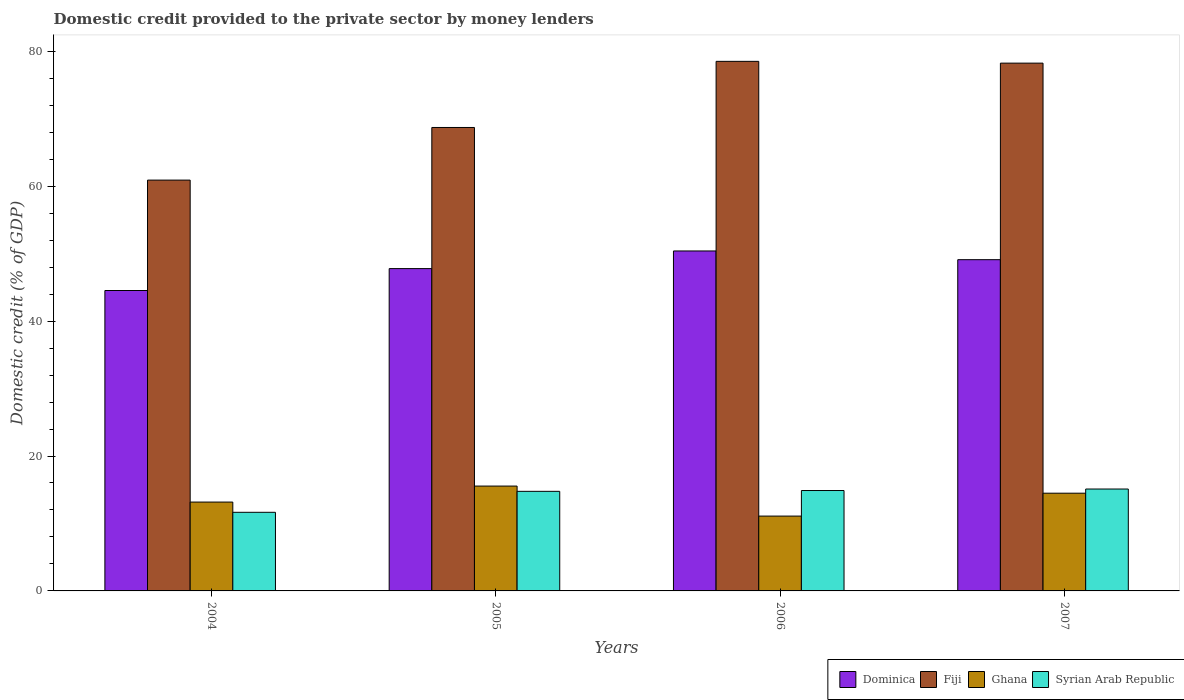How many groups of bars are there?
Ensure brevity in your answer.  4. Are the number of bars on each tick of the X-axis equal?
Your response must be concise. Yes. How many bars are there on the 4th tick from the right?
Your response must be concise. 4. In how many cases, is the number of bars for a given year not equal to the number of legend labels?
Keep it short and to the point. 0. What is the domestic credit provided to the private sector by money lenders in Ghana in 2005?
Ensure brevity in your answer.  15.54. Across all years, what is the maximum domestic credit provided to the private sector by money lenders in Ghana?
Make the answer very short. 15.54. Across all years, what is the minimum domestic credit provided to the private sector by money lenders in Ghana?
Give a very brief answer. 11.09. In which year was the domestic credit provided to the private sector by money lenders in Ghana maximum?
Make the answer very short. 2005. In which year was the domestic credit provided to the private sector by money lenders in Ghana minimum?
Ensure brevity in your answer.  2006. What is the total domestic credit provided to the private sector by money lenders in Dominica in the graph?
Offer a terse response. 191.83. What is the difference between the domestic credit provided to the private sector by money lenders in Ghana in 2004 and that in 2005?
Provide a short and direct response. -2.37. What is the difference between the domestic credit provided to the private sector by money lenders in Syrian Arab Republic in 2005 and the domestic credit provided to the private sector by money lenders in Ghana in 2004?
Ensure brevity in your answer.  1.59. What is the average domestic credit provided to the private sector by money lenders in Syrian Arab Republic per year?
Provide a succinct answer. 14.1. In the year 2007, what is the difference between the domestic credit provided to the private sector by money lenders in Fiji and domestic credit provided to the private sector by money lenders in Ghana?
Make the answer very short. 63.76. In how many years, is the domestic credit provided to the private sector by money lenders in Fiji greater than 28 %?
Ensure brevity in your answer.  4. What is the ratio of the domestic credit provided to the private sector by money lenders in Ghana in 2006 to that in 2007?
Give a very brief answer. 0.77. Is the domestic credit provided to the private sector by money lenders in Fiji in 2004 less than that in 2005?
Your response must be concise. Yes. Is the difference between the domestic credit provided to the private sector by money lenders in Fiji in 2004 and 2005 greater than the difference between the domestic credit provided to the private sector by money lenders in Ghana in 2004 and 2005?
Offer a very short reply. No. What is the difference between the highest and the second highest domestic credit provided to the private sector by money lenders in Dominica?
Provide a short and direct response. 1.29. What is the difference between the highest and the lowest domestic credit provided to the private sector by money lenders in Fiji?
Give a very brief answer. 17.6. Is the sum of the domestic credit provided to the private sector by money lenders in Dominica in 2004 and 2006 greater than the maximum domestic credit provided to the private sector by money lenders in Ghana across all years?
Your answer should be compact. Yes. Is it the case that in every year, the sum of the domestic credit provided to the private sector by money lenders in Fiji and domestic credit provided to the private sector by money lenders in Syrian Arab Republic is greater than the sum of domestic credit provided to the private sector by money lenders in Ghana and domestic credit provided to the private sector by money lenders in Dominica?
Make the answer very short. Yes. What does the 2nd bar from the left in 2007 represents?
Keep it short and to the point. Fiji. How many years are there in the graph?
Your response must be concise. 4. Are the values on the major ticks of Y-axis written in scientific E-notation?
Your response must be concise. No. Does the graph contain grids?
Provide a short and direct response. No. Where does the legend appear in the graph?
Your answer should be very brief. Bottom right. How are the legend labels stacked?
Ensure brevity in your answer.  Horizontal. What is the title of the graph?
Your answer should be very brief. Domestic credit provided to the private sector by money lenders. What is the label or title of the Y-axis?
Keep it short and to the point. Domestic credit (% of GDP). What is the Domestic credit (% of GDP) of Dominica in 2004?
Ensure brevity in your answer.  44.54. What is the Domestic credit (% of GDP) of Fiji in 2004?
Offer a very short reply. 60.91. What is the Domestic credit (% of GDP) of Ghana in 2004?
Make the answer very short. 13.17. What is the Domestic credit (% of GDP) in Syrian Arab Republic in 2004?
Make the answer very short. 11.65. What is the Domestic credit (% of GDP) in Dominica in 2005?
Provide a short and direct response. 47.78. What is the Domestic credit (% of GDP) in Fiji in 2005?
Your response must be concise. 68.71. What is the Domestic credit (% of GDP) of Ghana in 2005?
Give a very brief answer. 15.54. What is the Domestic credit (% of GDP) in Syrian Arab Republic in 2005?
Ensure brevity in your answer.  14.76. What is the Domestic credit (% of GDP) in Dominica in 2006?
Provide a succinct answer. 50.4. What is the Domestic credit (% of GDP) of Fiji in 2006?
Make the answer very short. 78.51. What is the Domestic credit (% of GDP) of Ghana in 2006?
Offer a terse response. 11.09. What is the Domestic credit (% of GDP) in Syrian Arab Republic in 2006?
Your response must be concise. 14.88. What is the Domestic credit (% of GDP) of Dominica in 2007?
Offer a very short reply. 49.11. What is the Domestic credit (% of GDP) in Fiji in 2007?
Give a very brief answer. 78.25. What is the Domestic credit (% of GDP) of Ghana in 2007?
Offer a terse response. 14.49. What is the Domestic credit (% of GDP) of Syrian Arab Republic in 2007?
Your answer should be very brief. 15.11. Across all years, what is the maximum Domestic credit (% of GDP) in Dominica?
Make the answer very short. 50.4. Across all years, what is the maximum Domestic credit (% of GDP) of Fiji?
Give a very brief answer. 78.51. Across all years, what is the maximum Domestic credit (% of GDP) of Ghana?
Make the answer very short. 15.54. Across all years, what is the maximum Domestic credit (% of GDP) in Syrian Arab Republic?
Your response must be concise. 15.11. Across all years, what is the minimum Domestic credit (% of GDP) of Dominica?
Your response must be concise. 44.54. Across all years, what is the minimum Domestic credit (% of GDP) in Fiji?
Your answer should be compact. 60.91. Across all years, what is the minimum Domestic credit (% of GDP) in Ghana?
Offer a terse response. 11.09. Across all years, what is the minimum Domestic credit (% of GDP) in Syrian Arab Republic?
Offer a terse response. 11.65. What is the total Domestic credit (% of GDP) in Dominica in the graph?
Offer a very short reply. 191.83. What is the total Domestic credit (% of GDP) in Fiji in the graph?
Provide a succinct answer. 286.37. What is the total Domestic credit (% of GDP) in Ghana in the graph?
Provide a short and direct response. 54.3. What is the total Domestic credit (% of GDP) of Syrian Arab Republic in the graph?
Your answer should be very brief. 56.41. What is the difference between the Domestic credit (% of GDP) of Dominica in 2004 and that in 2005?
Provide a short and direct response. -3.25. What is the difference between the Domestic credit (% of GDP) in Fiji in 2004 and that in 2005?
Ensure brevity in your answer.  -7.8. What is the difference between the Domestic credit (% of GDP) in Ghana in 2004 and that in 2005?
Your answer should be compact. -2.37. What is the difference between the Domestic credit (% of GDP) in Syrian Arab Republic in 2004 and that in 2005?
Ensure brevity in your answer.  -3.11. What is the difference between the Domestic credit (% of GDP) in Dominica in 2004 and that in 2006?
Keep it short and to the point. -5.86. What is the difference between the Domestic credit (% of GDP) in Fiji in 2004 and that in 2006?
Provide a succinct answer. -17.6. What is the difference between the Domestic credit (% of GDP) in Ghana in 2004 and that in 2006?
Give a very brief answer. 2.08. What is the difference between the Domestic credit (% of GDP) of Syrian Arab Republic in 2004 and that in 2006?
Offer a very short reply. -3.23. What is the difference between the Domestic credit (% of GDP) in Dominica in 2004 and that in 2007?
Provide a succinct answer. -4.57. What is the difference between the Domestic credit (% of GDP) of Fiji in 2004 and that in 2007?
Offer a very short reply. -17.34. What is the difference between the Domestic credit (% of GDP) in Ghana in 2004 and that in 2007?
Keep it short and to the point. -1.32. What is the difference between the Domestic credit (% of GDP) in Syrian Arab Republic in 2004 and that in 2007?
Offer a very short reply. -3.45. What is the difference between the Domestic credit (% of GDP) in Dominica in 2005 and that in 2006?
Offer a very short reply. -2.62. What is the difference between the Domestic credit (% of GDP) of Fiji in 2005 and that in 2006?
Your answer should be very brief. -9.8. What is the difference between the Domestic credit (% of GDP) of Ghana in 2005 and that in 2006?
Ensure brevity in your answer.  4.45. What is the difference between the Domestic credit (% of GDP) of Syrian Arab Republic in 2005 and that in 2006?
Provide a short and direct response. -0.12. What is the difference between the Domestic credit (% of GDP) in Dominica in 2005 and that in 2007?
Offer a very short reply. -1.32. What is the difference between the Domestic credit (% of GDP) of Fiji in 2005 and that in 2007?
Your answer should be compact. -9.54. What is the difference between the Domestic credit (% of GDP) of Ghana in 2005 and that in 2007?
Offer a terse response. 1.06. What is the difference between the Domestic credit (% of GDP) in Syrian Arab Republic in 2005 and that in 2007?
Keep it short and to the point. -0.34. What is the difference between the Domestic credit (% of GDP) in Dominica in 2006 and that in 2007?
Give a very brief answer. 1.29. What is the difference between the Domestic credit (% of GDP) of Fiji in 2006 and that in 2007?
Offer a terse response. 0.26. What is the difference between the Domestic credit (% of GDP) of Ghana in 2006 and that in 2007?
Your answer should be compact. -3.39. What is the difference between the Domestic credit (% of GDP) of Syrian Arab Republic in 2006 and that in 2007?
Provide a succinct answer. -0.22. What is the difference between the Domestic credit (% of GDP) in Dominica in 2004 and the Domestic credit (% of GDP) in Fiji in 2005?
Offer a very short reply. -24.17. What is the difference between the Domestic credit (% of GDP) in Dominica in 2004 and the Domestic credit (% of GDP) in Ghana in 2005?
Provide a succinct answer. 28.99. What is the difference between the Domestic credit (% of GDP) in Dominica in 2004 and the Domestic credit (% of GDP) in Syrian Arab Republic in 2005?
Your answer should be very brief. 29.77. What is the difference between the Domestic credit (% of GDP) in Fiji in 2004 and the Domestic credit (% of GDP) in Ghana in 2005?
Your response must be concise. 45.36. What is the difference between the Domestic credit (% of GDP) in Fiji in 2004 and the Domestic credit (% of GDP) in Syrian Arab Republic in 2005?
Offer a very short reply. 46.14. What is the difference between the Domestic credit (% of GDP) in Ghana in 2004 and the Domestic credit (% of GDP) in Syrian Arab Republic in 2005?
Keep it short and to the point. -1.59. What is the difference between the Domestic credit (% of GDP) of Dominica in 2004 and the Domestic credit (% of GDP) of Fiji in 2006?
Make the answer very short. -33.97. What is the difference between the Domestic credit (% of GDP) in Dominica in 2004 and the Domestic credit (% of GDP) in Ghana in 2006?
Provide a short and direct response. 33.44. What is the difference between the Domestic credit (% of GDP) of Dominica in 2004 and the Domestic credit (% of GDP) of Syrian Arab Republic in 2006?
Make the answer very short. 29.65. What is the difference between the Domestic credit (% of GDP) of Fiji in 2004 and the Domestic credit (% of GDP) of Ghana in 2006?
Your response must be concise. 49.81. What is the difference between the Domestic credit (% of GDP) in Fiji in 2004 and the Domestic credit (% of GDP) in Syrian Arab Republic in 2006?
Your answer should be compact. 46.02. What is the difference between the Domestic credit (% of GDP) of Ghana in 2004 and the Domestic credit (% of GDP) of Syrian Arab Republic in 2006?
Provide a short and direct response. -1.71. What is the difference between the Domestic credit (% of GDP) of Dominica in 2004 and the Domestic credit (% of GDP) of Fiji in 2007?
Make the answer very short. -33.71. What is the difference between the Domestic credit (% of GDP) in Dominica in 2004 and the Domestic credit (% of GDP) in Ghana in 2007?
Offer a terse response. 30.05. What is the difference between the Domestic credit (% of GDP) in Dominica in 2004 and the Domestic credit (% of GDP) in Syrian Arab Republic in 2007?
Ensure brevity in your answer.  29.43. What is the difference between the Domestic credit (% of GDP) in Fiji in 2004 and the Domestic credit (% of GDP) in Ghana in 2007?
Provide a succinct answer. 46.42. What is the difference between the Domestic credit (% of GDP) of Fiji in 2004 and the Domestic credit (% of GDP) of Syrian Arab Republic in 2007?
Your answer should be compact. 45.8. What is the difference between the Domestic credit (% of GDP) in Ghana in 2004 and the Domestic credit (% of GDP) in Syrian Arab Republic in 2007?
Your answer should be compact. -1.94. What is the difference between the Domestic credit (% of GDP) in Dominica in 2005 and the Domestic credit (% of GDP) in Fiji in 2006?
Your response must be concise. -30.73. What is the difference between the Domestic credit (% of GDP) of Dominica in 2005 and the Domestic credit (% of GDP) of Ghana in 2006?
Offer a very short reply. 36.69. What is the difference between the Domestic credit (% of GDP) in Dominica in 2005 and the Domestic credit (% of GDP) in Syrian Arab Republic in 2006?
Make the answer very short. 32.9. What is the difference between the Domestic credit (% of GDP) in Fiji in 2005 and the Domestic credit (% of GDP) in Ghana in 2006?
Make the answer very short. 57.61. What is the difference between the Domestic credit (% of GDP) in Fiji in 2005 and the Domestic credit (% of GDP) in Syrian Arab Republic in 2006?
Your response must be concise. 53.82. What is the difference between the Domestic credit (% of GDP) in Ghana in 2005 and the Domestic credit (% of GDP) in Syrian Arab Republic in 2006?
Provide a short and direct response. 0.66. What is the difference between the Domestic credit (% of GDP) in Dominica in 2005 and the Domestic credit (% of GDP) in Fiji in 2007?
Provide a succinct answer. -30.46. What is the difference between the Domestic credit (% of GDP) of Dominica in 2005 and the Domestic credit (% of GDP) of Ghana in 2007?
Give a very brief answer. 33.3. What is the difference between the Domestic credit (% of GDP) in Dominica in 2005 and the Domestic credit (% of GDP) in Syrian Arab Republic in 2007?
Offer a terse response. 32.68. What is the difference between the Domestic credit (% of GDP) of Fiji in 2005 and the Domestic credit (% of GDP) of Ghana in 2007?
Offer a very short reply. 54.22. What is the difference between the Domestic credit (% of GDP) of Fiji in 2005 and the Domestic credit (% of GDP) of Syrian Arab Republic in 2007?
Your answer should be compact. 53.6. What is the difference between the Domestic credit (% of GDP) of Ghana in 2005 and the Domestic credit (% of GDP) of Syrian Arab Republic in 2007?
Your answer should be compact. 0.44. What is the difference between the Domestic credit (% of GDP) of Dominica in 2006 and the Domestic credit (% of GDP) of Fiji in 2007?
Provide a succinct answer. -27.85. What is the difference between the Domestic credit (% of GDP) in Dominica in 2006 and the Domestic credit (% of GDP) in Ghana in 2007?
Your response must be concise. 35.91. What is the difference between the Domestic credit (% of GDP) in Dominica in 2006 and the Domestic credit (% of GDP) in Syrian Arab Republic in 2007?
Ensure brevity in your answer.  35.29. What is the difference between the Domestic credit (% of GDP) in Fiji in 2006 and the Domestic credit (% of GDP) in Ghana in 2007?
Keep it short and to the point. 64.02. What is the difference between the Domestic credit (% of GDP) of Fiji in 2006 and the Domestic credit (% of GDP) of Syrian Arab Republic in 2007?
Offer a terse response. 63.4. What is the difference between the Domestic credit (% of GDP) of Ghana in 2006 and the Domestic credit (% of GDP) of Syrian Arab Republic in 2007?
Your answer should be compact. -4.01. What is the average Domestic credit (% of GDP) in Dominica per year?
Your response must be concise. 47.96. What is the average Domestic credit (% of GDP) in Fiji per year?
Offer a terse response. 71.59. What is the average Domestic credit (% of GDP) in Ghana per year?
Give a very brief answer. 13.57. What is the average Domestic credit (% of GDP) in Syrian Arab Republic per year?
Your answer should be compact. 14.1. In the year 2004, what is the difference between the Domestic credit (% of GDP) in Dominica and Domestic credit (% of GDP) in Fiji?
Provide a short and direct response. -16.37. In the year 2004, what is the difference between the Domestic credit (% of GDP) of Dominica and Domestic credit (% of GDP) of Ghana?
Make the answer very short. 31.36. In the year 2004, what is the difference between the Domestic credit (% of GDP) in Dominica and Domestic credit (% of GDP) in Syrian Arab Republic?
Provide a short and direct response. 32.88. In the year 2004, what is the difference between the Domestic credit (% of GDP) in Fiji and Domestic credit (% of GDP) in Ghana?
Ensure brevity in your answer.  47.73. In the year 2004, what is the difference between the Domestic credit (% of GDP) of Fiji and Domestic credit (% of GDP) of Syrian Arab Republic?
Your response must be concise. 49.25. In the year 2004, what is the difference between the Domestic credit (% of GDP) of Ghana and Domestic credit (% of GDP) of Syrian Arab Republic?
Your answer should be very brief. 1.52. In the year 2005, what is the difference between the Domestic credit (% of GDP) of Dominica and Domestic credit (% of GDP) of Fiji?
Your response must be concise. -20.92. In the year 2005, what is the difference between the Domestic credit (% of GDP) of Dominica and Domestic credit (% of GDP) of Ghana?
Offer a terse response. 32.24. In the year 2005, what is the difference between the Domestic credit (% of GDP) of Dominica and Domestic credit (% of GDP) of Syrian Arab Republic?
Provide a short and direct response. 33.02. In the year 2005, what is the difference between the Domestic credit (% of GDP) of Fiji and Domestic credit (% of GDP) of Ghana?
Provide a succinct answer. 53.16. In the year 2005, what is the difference between the Domestic credit (% of GDP) of Fiji and Domestic credit (% of GDP) of Syrian Arab Republic?
Keep it short and to the point. 53.94. In the year 2005, what is the difference between the Domestic credit (% of GDP) of Ghana and Domestic credit (% of GDP) of Syrian Arab Republic?
Offer a terse response. 0.78. In the year 2006, what is the difference between the Domestic credit (% of GDP) of Dominica and Domestic credit (% of GDP) of Fiji?
Give a very brief answer. -28.11. In the year 2006, what is the difference between the Domestic credit (% of GDP) of Dominica and Domestic credit (% of GDP) of Ghana?
Keep it short and to the point. 39.31. In the year 2006, what is the difference between the Domestic credit (% of GDP) in Dominica and Domestic credit (% of GDP) in Syrian Arab Republic?
Provide a succinct answer. 35.52. In the year 2006, what is the difference between the Domestic credit (% of GDP) of Fiji and Domestic credit (% of GDP) of Ghana?
Make the answer very short. 67.42. In the year 2006, what is the difference between the Domestic credit (% of GDP) in Fiji and Domestic credit (% of GDP) in Syrian Arab Republic?
Provide a succinct answer. 63.63. In the year 2006, what is the difference between the Domestic credit (% of GDP) in Ghana and Domestic credit (% of GDP) in Syrian Arab Republic?
Ensure brevity in your answer.  -3.79. In the year 2007, what is the difference between the Domestic credit (% of GDP) in Dominica and Domestic credit (% of GDP) in Fiji?
Give a very brief answer. -29.14. In the year 2007, what is the difference between the Domestic credit (% of GDP) in Dominica and Domestic credit (% of GDP) in Ghana?
Your response must be concise. 34.62. In the year 2007, what is the difference between the Domestic credit (% of GDP) in Dominica and Domestic credit (% of GDP) in Syrian Arab Republic?
Ensure brevity in your answer.  34. In the year 2007, what is the difference between the Domestic credit (% of GDP) of Fiji and Domestic credit (% of GDP) of Ghana?
Your response must be concise. 63.76. In the year 2007, what is the difference between the Domestic credit (% of GDP) of Fiji and Domestic credit (% of GDP) of Syrian Arab Republic?
Your answer should be compact. 63.14. In the year 2007, what is the difference between the Domestic credit (% of GDP) of Ghana and Domestic credit (% of GDP) of Syrian Arab Republic?
Ensure brevity in your answer.  -0.62. What is the ratio of the Domestic credit (% of GDP) of Dominica in 2004 to that in 2005?
Offer a terse response. 0.93. What is the ratio of the Domestic credit (% of GDP) of Fiji in 2004 to that in 2005?
Your response must be concise. 0.89. What is the ratio of the Domestic credit (% of GDP) in Ghana in 2004 to that in 2005?
Keep it short and to the point. 0.85. What is the ratio of the Domestic credit (% of GDP) in Syrian Arab Republic in 2004 to that in 2005?
Your answer should be compact. 0.79. What is the ratio of the Domestic credit (% of GDP) in Dominica in 2004 to that in 2006?
Your answer should be very brief. 0.88. What is the ratio of the Domestic credit (% of GDP) of Fiji in 2004 to that in 2006?
Your answer should be compact. 0.78. What is the ratio of the Domestic credit (% of GDP) of Ghana in 2004 to that in 2006?
Keep it short and to the point. 1.19. What is the ratio of the Domestic credit (% of GDP) in Syrian Arab Republic in 2004 to that in 2006?
Give a very brief answer. 0.78. What is the ratio of the Domestic credit (% of GDP) in Dominica in 2004 to that in 2007?
Make the answer very short. 0.91. What is the ratio of the Domestic credit (% of GDP) in Fiji in 2004 to that in 2007?
Offer a very short reply. 0.78. What is the ratio of the Domestic credit (% of GDP) in Ghana in 2004 to that in 2007?
Offer a very short reply. 0.91. What is the ratio of the Domestic credit (% of GDP) of Syrian Arab Republic in 2004 to that in 2007?
Provide a short and direct response. 0.77. What is the ratio of the Domestic credit (% of GDP) in Dominica in 2005 to that in 2006?
Give a very brief answer. 0.95. What is the ratio of the Domestic credit (% of GDP) of Fiji in 2005 to that in 2006?
Offer a very short reply. 0.88. What is the ratio of the Domestic credit (% of GDP) in Ghana in 2005 to that in 2006?
Ensure brevity in your answer.  1.4. What is the ratio of the Domestic credit (% of GDP) of Syrian Arab Republic in 2005 to that in 2006?
Make the answer very short. 0.99. What is the ratio of the Domestic credit (% of GDP) in Dominica in 2005 to that in 2007?
Provide a short and direct response. 0.97. What is the ratio of the Domestic credit (% of GDP) in Fiji in 2005 to that in 2007?
Offer a very short reply. 0.88. What is the ratio of the Domestic credit (% of GDP) in Ghana in 2005 to that in 2007?
Ensure brevity in your answer.  1.07. What is the ratio of the Domestic credit (% of GDP) of Syrian Arab Republic in 2005 to that in 2007?
Your answer should be very brief. 0.98. What is the ratio of the Domestic credit (% of GDP) in Dominica in 2006 to that in 2007?
Provide a short and direct response. 1.03. What is the ratio of the Domestic credit (% of GDP) in Ghana in 2006 to that in 2007?
Make the answer very short. 0.77. What is the ratio of the Domestic credit (% of GDP) of Syrian Arab Republic in 2006 to that in 2007?
Give a very brief answer. 0.99. What is the difference between the highest and the second highest Domestic credit (% of GDP) of Dominica?
Provide a succinct answer. 1.29. What is the difference between the highest and the second highest Domestic credit (% of GDP) of Fiji?
Ensure brevity in your answer.  0.26. What is the difference between the highest and the second highest Domestic credit (% of GDP) in Ghana?
Your answer should be very brief. 1.06. What is the difference between the highest and the second highest Domestic credit (% of GDP) of Syrian Arab Republic?
Give a very brief answer. 0.22. What is the difference between the highest and the lowest Domestic credit (% of GDP) in Dominica?
Give a very brief answer. 5.86. What is the difference between the highest and the lowest Domestic credit (% of GDP) of Fiji?
Your response must be concise. 17.6. What is the difference between the highest and the lowest Domestic credit (% of GDP) of Ghana?
Provide a succinct answer. 4.45. What is the difference between the highest and the lowest Domestic credit (% of GDP) in Syrian Arab Republic?
Keep it short and to the point. 3.45. 